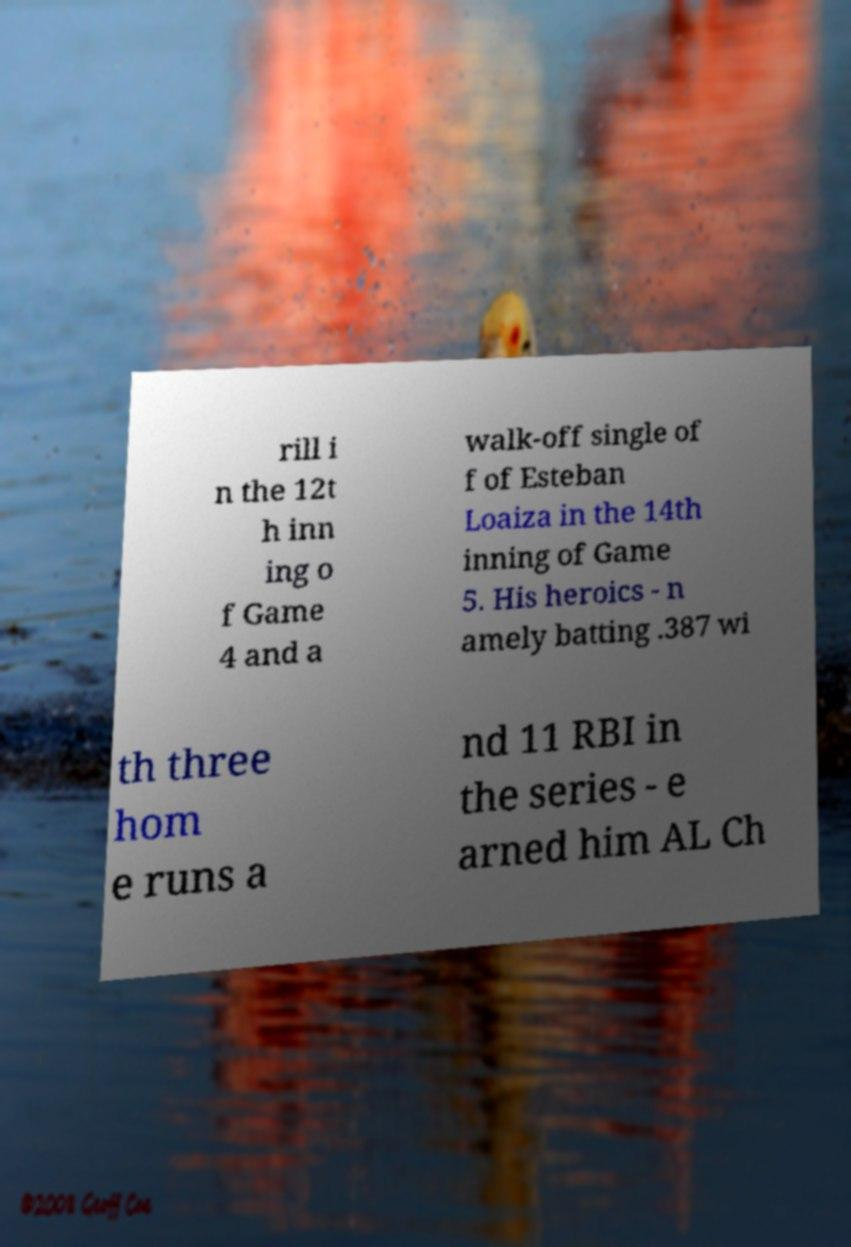Can you accurately transcribe the text from the provided image for me? rill i n the 12t h inn ing o f Game 4 and a walk-off single of f of Esteban Loaiza in the 14th inning of Game 5. His heroics - n amely batting .387 wi th three hom e runs a nd 11 RBI in the series - e arned him AL Ch 